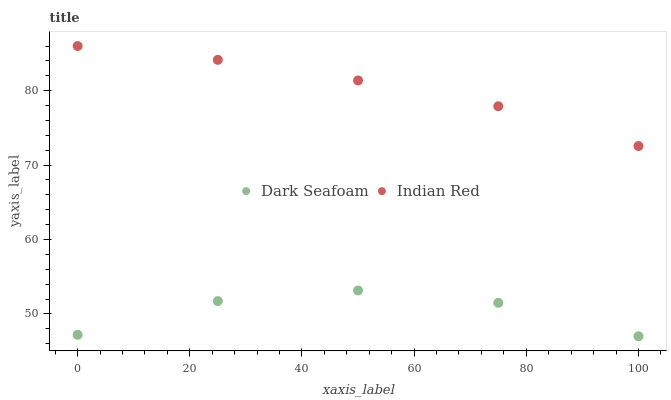Does Dark Seafoam have the minimum area under the curve?
Answer yes or no. Yes. Does Indian Red have the maximum area under the curve?
Answer yes or no. Yes. Does Indian Red have the minimum area under the curve?
Answer yes or no. No. Is Indian Red the smoothest?
Answer yes or no. Yes. Is Dark Seafoam the roughest?
Answer yes or no. Yes. Is Indian Red the roughest?
Answer yes or no. No. Does Dark Seafoam have the lowest value?
Answer yes or no. Yes. Does Indian Red have the lowest value?
Answer yes or no. No. Does Indian Red have the highest value?
Answer yes or no. Yes. Is Dark Seafoam less than Indian Red?
Answer yes or no. Yes. Is Indian Red greater than Dark Seafoam?
Answer yes or no. Yes. Does Dark Seafoam intersect Indian Red?
Answer yes or no. No. 